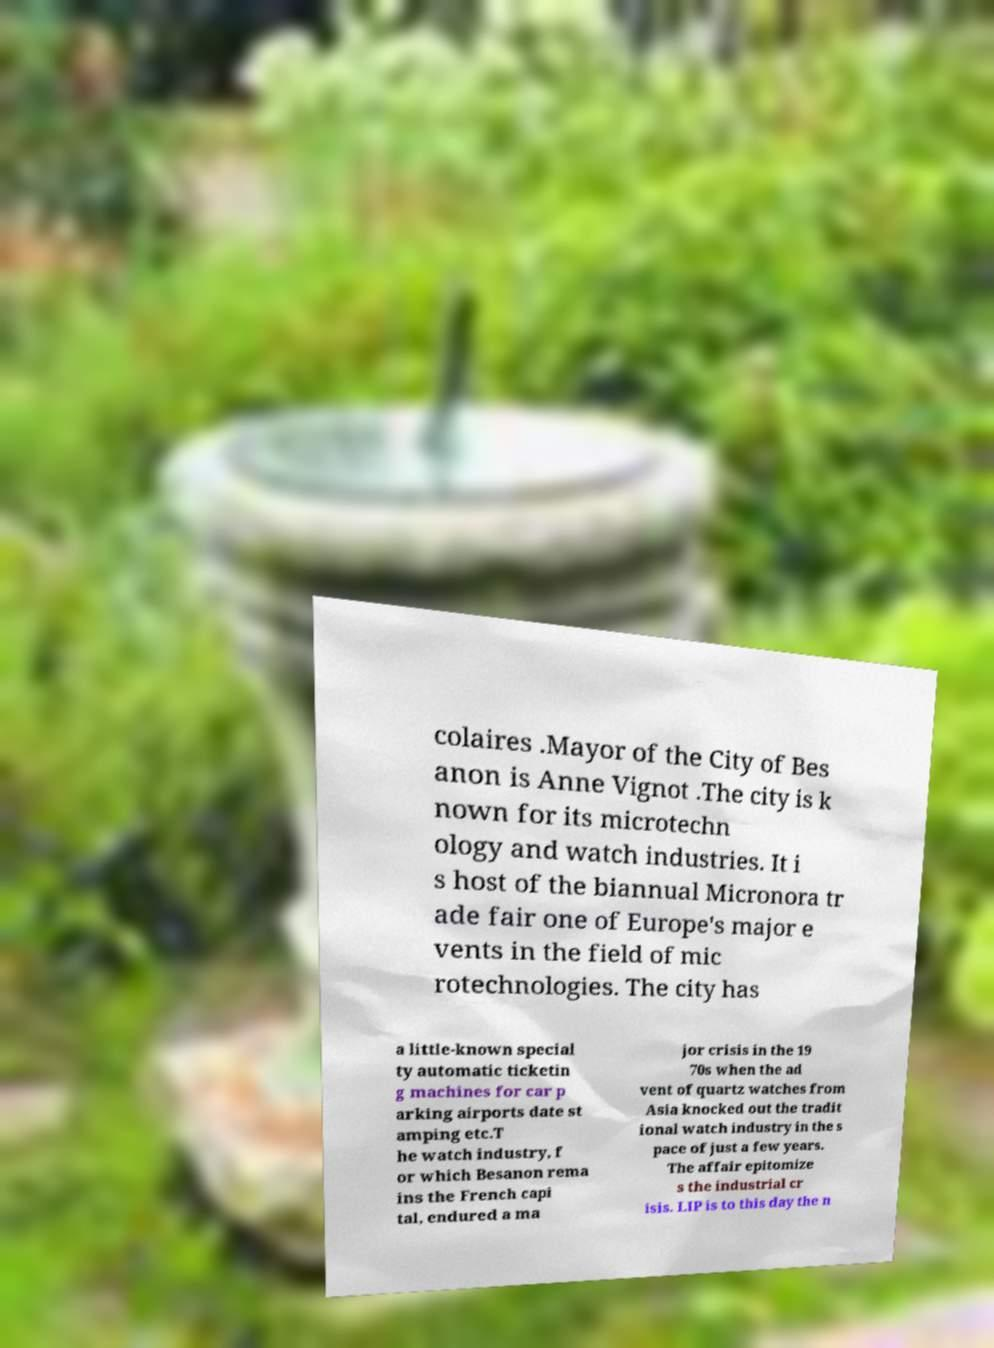Could you extract and type out the text from this image? colaires .Mayor of the City of Bes anon is Anne Vignot .The city is k nown for its microtechn ology and watch industries. It i s host of the biannual Micronora tr ade fair one of Europe's major e vents in the field of mic rotechnologies. The city has a little-known special ty automatic ticketin g machines for car p arking airports date st amping etc.T he watch industry, f or which Besanon rema ins the French capi tal, endured a ma jor crisis in the 19 70s when the ad vent of quartz watches from Asia knocked out the tradit ional watch industry in the s pace of just a few years. The affair epitomize s the industrial cr isis. LIP is to this day the n 